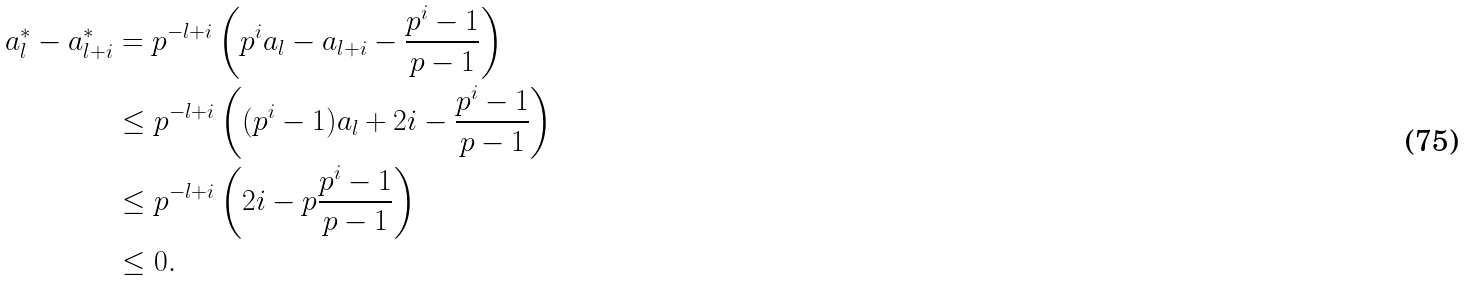Convert formula to latex. <formula><loc_0><loc_0><loc_500><loc_500>a _ { l } ^ { * } - a _ { l + i } ^ { * } & = p ^ { - { l + i } } \left ( p ^ { i } a _ { l } - a _ { l + i } - \frac { p ^ { i } - 1 } { p - 1 } \right ) \\ & \leq p ^ { - { l + i } } \left ( ( p ^ { i } - 1 ) a _ { l } + 2 i - \frac { p ^ { i } - 1 } { p - 1 } \right ) \\ & \leq p ^ { - { l + i } } \left ( 2 i - p \frac { p ^ { i } - 1 } { p - 1 } \right ) \\ & \leq 0 .</formula> 